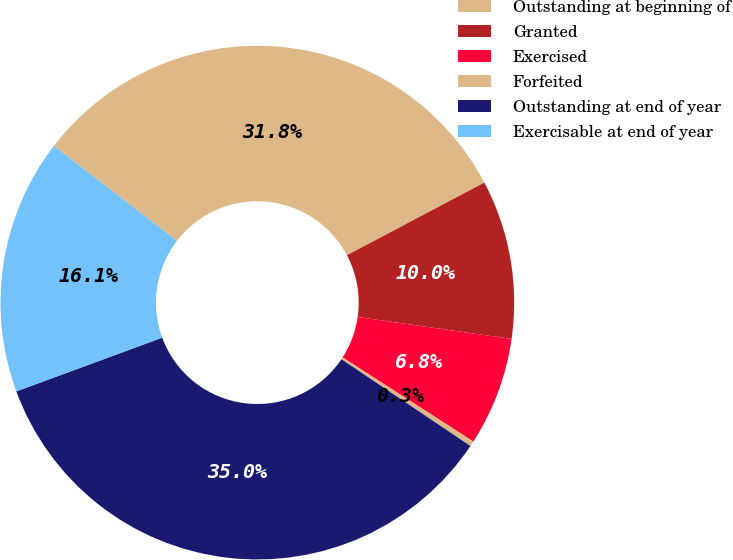Convert chart. <chart><loc_0><loc_0><loc_500><loc_500><pie_chart><fcel>Outstanding at beginning of<fcel>Granted<fcel>Exercised<fcel>Forfeited<fcel>Outstanding at end of year<fcel>Exercisable at end of year<nl><fcel>31.81%<fcel>10.0%<fcel>6.84%<fcel>0.33%<fcel>34.96%<fcel>16.07%<nl></chart> 